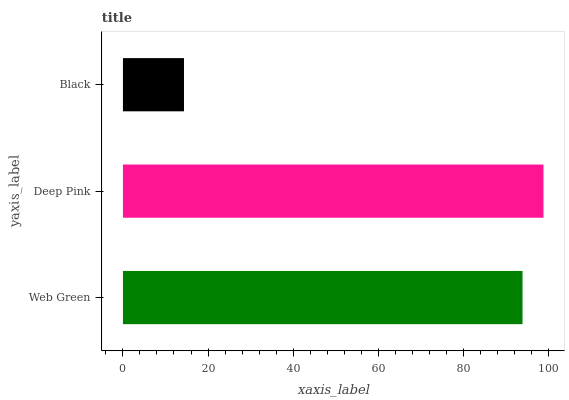Is Black the minimum?
Answer yes or no. Yes. Is Deep Pink the maximum?
Answer yes or no. Yes. Is Deep Pink the minimum?
Answer yes or no. No. Is Black the maximum?
Answer yes or no. No. Is Deep Pink greater than Black?
Answer yes or no. Yes. Is Black less than Deep Pink?
Answer yes or no. Yes. Is Black greater than Deep Pink?
Answer yes or no. No. Is Deep Pink less than Black?
Answer yes or no. No. Is Web Green the high median?
Answer yes or no. Yes. Is Web Green the low median?
Answer yes or no. Yes. Is Black the high median?
Answer yes or no. No. Is Black the low median?
Answer yes or no. No. 